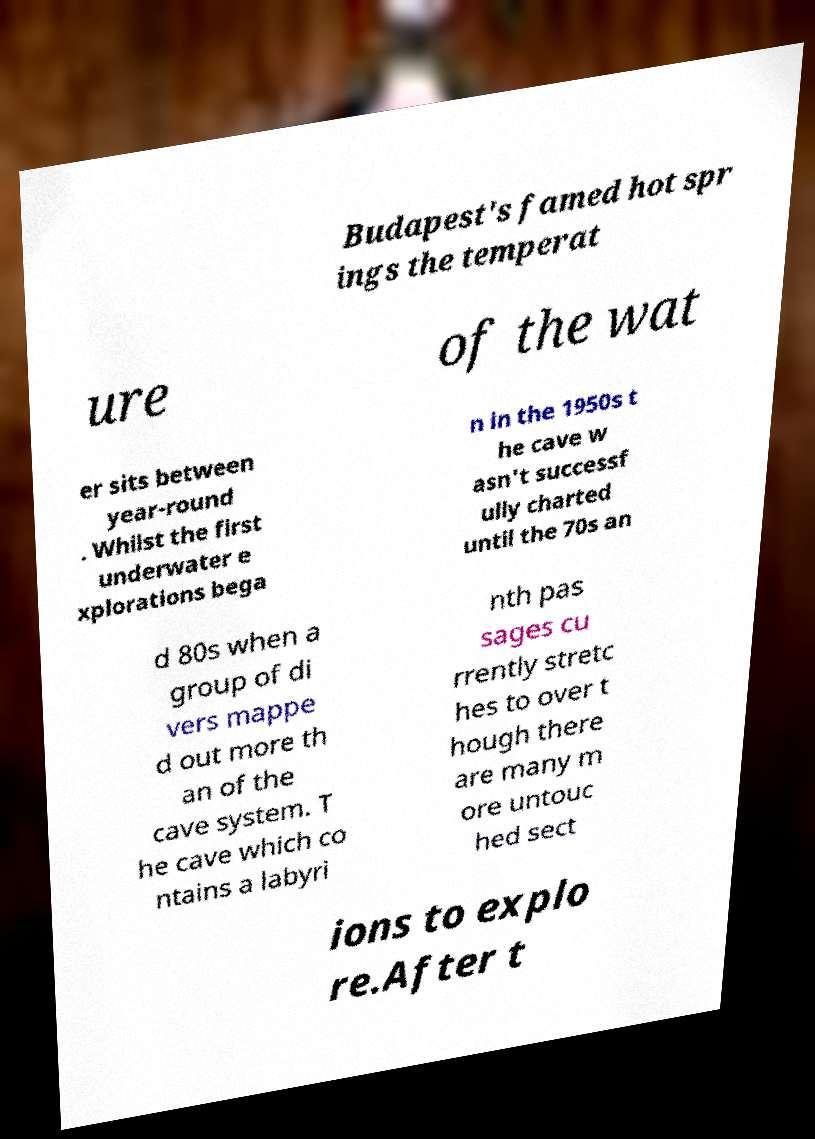I need the written content from this picture converted into text. Can you do that? Budapest's famed hot spr ings the temperat ure of the wat er sits between year-round . Whilst the first underwater e xplorations bega n in the 1950s t he cave w asn't successf ully charted until the 70s an d 80s when a group of di vers mappe d out more th an of the cave system. T he cave which co ntains a labyri nth pas sages cu rrently stretc hes to over t hough there are many m ore untouc hed sect ions to explo re.After t 